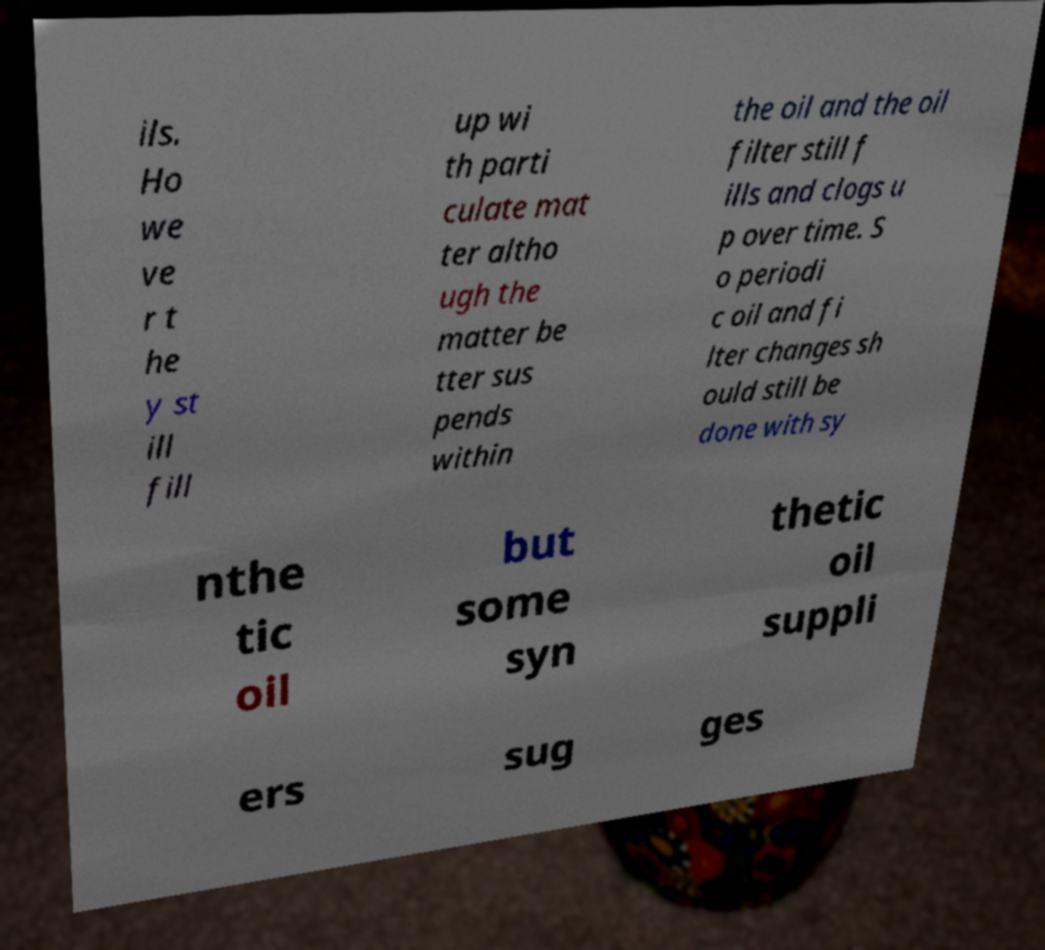Can you accurately transcribe the text from the provided image for me? ils. Ho we ve r t he y st ill fill up wi th parti culate mat ter altho ugh the matter be tter sus pends within the oil and the oil filter still f ills and clogs u p over time. S o periodi c oil and fi lter changes sh ould still be done with sy nthe tic oil but some syn thetic oil suppli ers sug ges 